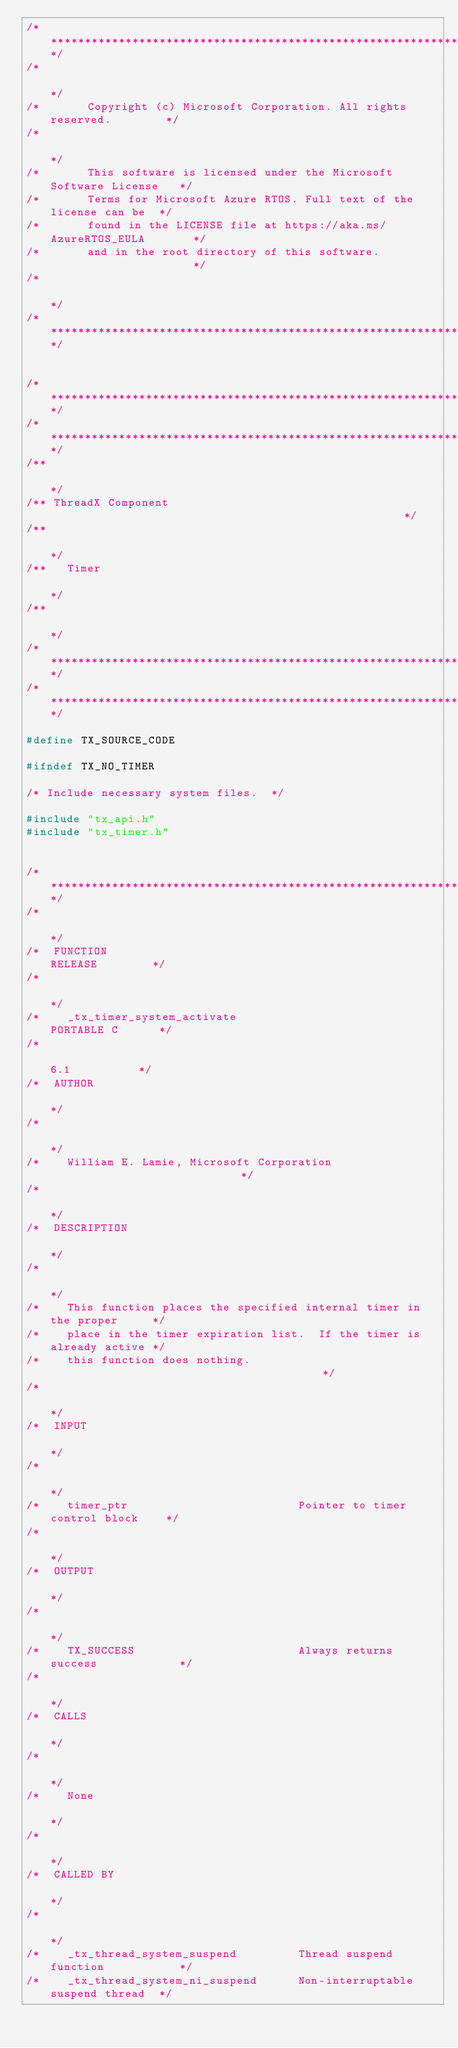Convert code to text. <code><loc_0><loc_0><loc_500><loc_500><_C_>/**************************************************************************/
/*                                                                        */
/*       Copyright (c) Microsoft Corporation. All rights reserved.        */
/*                                                                        */
/*       This software is licensed under the Microsoft Software License   */
/*       Terms for Microsoft Azure RTOS. Full text of the license can be  */
/*       found in the LICENSE file at https://aka.ms/AzureRTOS_EULA       */
/*       and in the root directory of this software.                      */
/*                                                                        */
/**************************************************************************/


/**************************************************************************/
/**************************************************************************/
/**                                                                       */
/** ThreadX Component                                                     */
/**                                                                       */
/**   Timer                                                               */
/**                                                                       */
/**************************************************************************/
/**************************************************************************/

#define TX_SOURCE_CODE

#ifndef TX_NO_TIMER

/* Include necessary system files.  */

#include "tx_api.h"
#include "tx_timer.h"


/**************************************************************************/
/*                                                                        */
/*  FUNCTION                                               RELEASE        */
/*                                                                        */
/*    _tx_timer_system_activate                           PORTABLE C      */
/*                                                           6.1          */
/*  AUTHOR                                                                */
/*                                                                        */
/*    William E. Lamie, Microsoft Corporation                             */
/*                                                                        */
/*  DESCRIPTION                                                           */
/*                                                                        */
/*    This function places the specified internal timer in the proper     */
/*    place in the timer expiration list.  If the timer is already active */
/*    this function does nothing.                                         */
/*                                                                        */
/*  INPUT                                                                 */
/*                                                                        */
/*    timer_ptr                         Pointer to timer control block    */
/*                                                                        */
/*  OUTPUT                                                                */
/*                                                                        */
/*    TX_SUCCESS                        Always returns success            */
/*                                                                        */
/*  CALLS                                                                 */
/*                                                                        */
/*    None                                                                */
/*                                                                        */
/*  CALLED BY                                                             */
/*                                                                        */
/*    _tx_thread_system_suspend         Thread suspend function           */
/*    _tx_thread_system_ni_suspend      Non-interruptable suspend thread  */</code> 